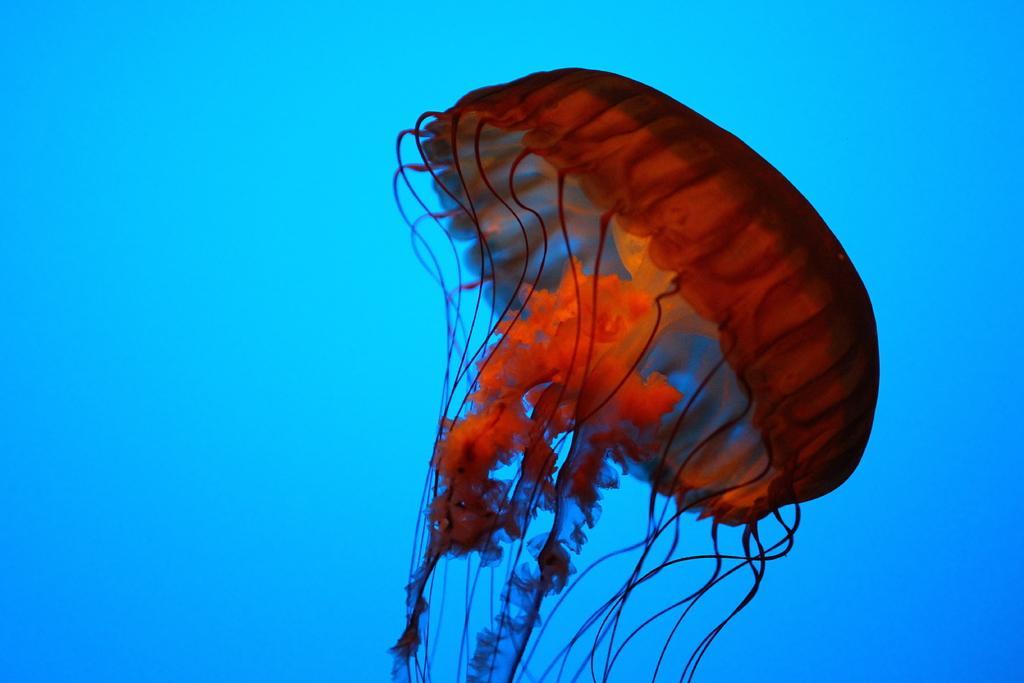How would you summarize this image in a sentence or two? The picture is taken in the water. In the center of the picture there is a jellyfish. 